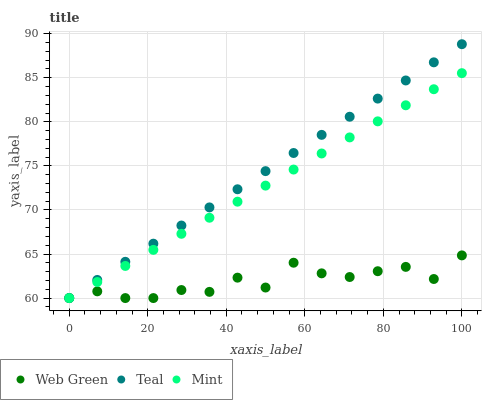Does Web Green have the minimum area under the curve?
Answer yes or no. Yes. Does Teal have the maximum area under the curve?
Answer yes or no. Yes. Does Teal have the minimum area under the curve?
Answer yes or no. No. Does Web Green have the maximum area under the curve?
Answer yes or no. No. Is Mint the smoothest?
Answer yes or no. Yes. Is Web Green the roughest?
Answer yes or no. Yes. Is Teal the smoothest?
Answer yes or no. No. Is Teal the roughest?
Answer yes or no. No. Does Mint have the lowest value?
Answer yes or no. Yes. Does Teal have the highest value?
Answer yes or no. Yes. Does Web Green have the highest value?
Answer yes or no. No. Does Teal intersect Mint?
Answer yes or no. Yes. Is Teal less than Mint?
Answer yes or no. No. Is Teal greater than Mint?
Answer yes or no. No. 